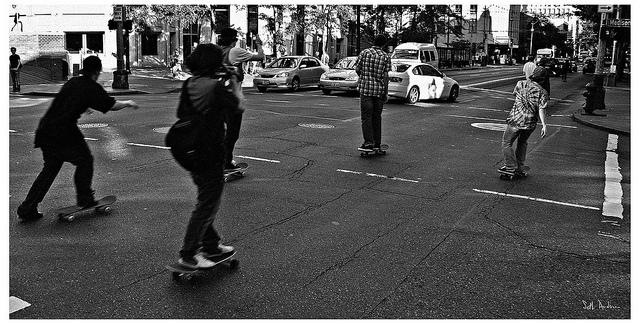Does this gadget with wheels and a board demonstrate how most people get to work?
Answer briefly. No. What are the people doing in the street?
Give a very brief answer. Skateboarding. Is the picture in color?
Keep it brief. No. 